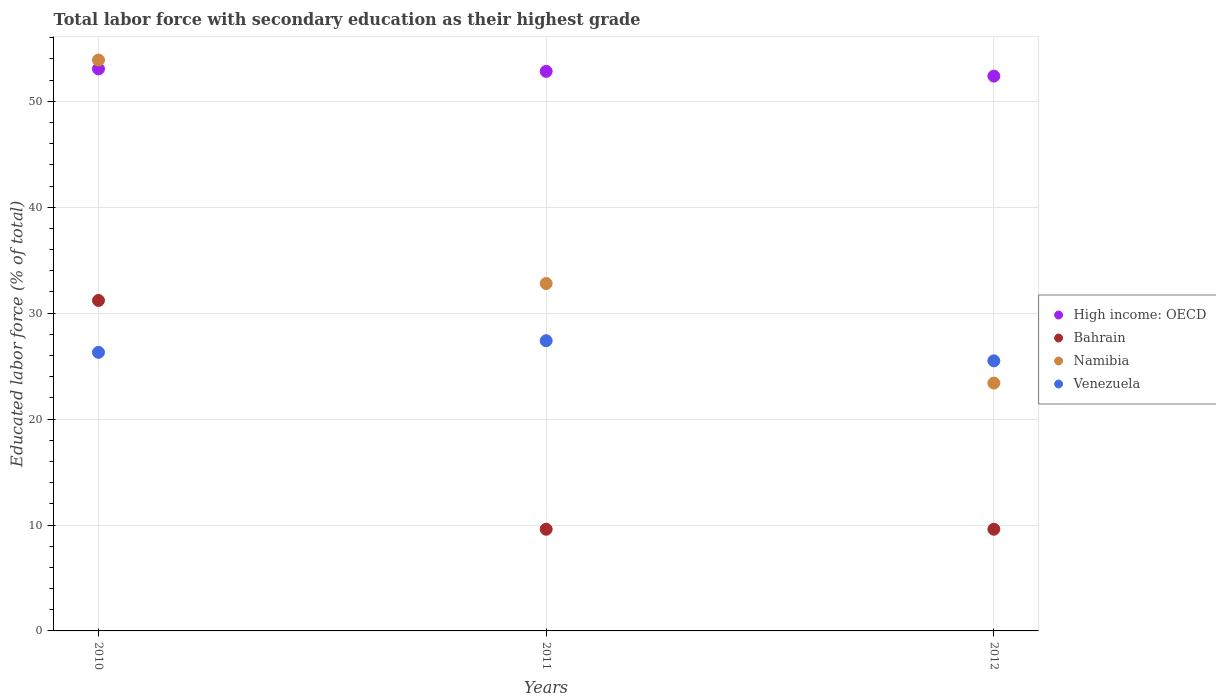How many different coloured dotlines are there?
Your answer should be compact. 4. Is the number of dotlines equal to the number of legend labels?
Provide a short and direct response. Yes. What is the percentage of total labor force with primary education in Bahrain in 2010?
Your answer should be very brief. 31.2. Across all years, what is the maximum percentage of total labor force with primary education in High income: OECD?
Provide a short and direct response. 53.07. Across all years, what is the minimum percentage of total labor force with primary education in High income: OECD?
Offer a terse response. 52.38. In which year was the percentage of total labor force with primary education in Venezuela maximum?
Keep it short and to the point. 2011. What is the total percentage of total labor force with primary education in Venezuela in the graph?
Give a very brief answer. 79.2. What is the difference between the percentage of total labor force with primary education in High income: OECD in 2011 and that in 2012?
Your answer should be very brief. 0.45. What is the difference between the percentage of total labor force with primary education in Namibia in 2011 and the percentage of total labor force with primary education in Venezuela in 2010?
Make the answer very short. 6.5. What is the average percentage of total labor force with primary education in High income: OECD per year?
Offer a terse response. 52.76. In the year 2010, what is the difference between the percentage of total labor force with primary education in High income: OECD and percentage of total labor force with primary education in Namibia?
Offer a terse response. -0.83. What is the ratio of the percentage of total labor force with primary education in High income: OECD in 2010 to that in 2012?
Provide a succinct answer. 1.01. Is the percentage of total labor force with primary education in High income: OECD in 2010 less than that in 2012?
Offer a terse response. No. Is the difference between the percentage of total labor force with primary education in High income: OECD in 2011 and 2012 greater than the difference between the percentage of total labor force with primary education in Namibia in 2011 and 2012?
Your answer should be compact. No. What is the difference between the highest and the second highest percentage of total labor force with primary education in High income: OECD?
Provide a succinct answer. 0.24. What is the difference between the highest and the lowest percentage of total labor force with primary education in High income: OECD?
Your answer should be very brief. 0.68. Does the percentage of total labor force with primary education in Namibia monotonically increase over the years?
Provide a succinct answer. No. Is the percentage of total labor force with primary education in High income: OECD strictly greater than the percentage of total labor force with primary education in Bahrain over the years?
Provide a short and direct response. Yes. What is the difference between two consecutive major ticks on the Y-axis?
Offer a terse response. 10. Are the values on the major ticks of Y-axis written in scientific E-notation?
Make the answer very short. No. Does the graph contain any zero values?
Keep it short and to the point. No. Where does the legend appear in the graph?
Keep it short and to the point. Center right. How are the legend labels stacked?
Your answer should be compact. Vertical. What is the title of the graph?
Keep it short and to the point. Total labor force with secondary education as their highest grade. Does "Bahrain" appear as one of the legend labels in the graph?
Offer a terse response. Yes. What is the label or title of the X-axis?
Give a very brief answer. Years. What is the label or title of the Y-axis?
Ensure brevity in your answer.  Educated labor force (% of total). What is the Educated labor force (% of total) of High income: OECD in 2010?
Provide a succinct answer. 53.07. What is the Educated labor force (% of total) of Bahrain in 2010?
Give a very brief answer. 31.2. What is the Educated labor force (% of total) of Namibia in 2010?
Give a very brief answer. 53.9. What is the Educated labor force (% of total) of Venezuela in 2010?
Keep it short and to the point. 26.3. What is the Educated labor force (% of total) of High income: OECD in 2011?
Your answer should be compact. 52.83. What is the Educated labor force (% of total) of Bahrain in 2011?
Offer a terse response. 9.6. What is the Educated labor force (% of total) in Namibia in 2011?
Provide a short and direct response. 32.8. What is the Educated labor force (% of total) in Venezuela in 2011?
Ensure brevity in your answer.  27.4. What is the Educated labor force (% of total) of High income: OECD in 2012?
Keep it short and to the point. 52.38. What is the Educated labor force (% of total) in Bahrain in 2012?
Provide a succinct answer. 9.6. What is the Educated labor force (% of total) of Namibia in 2012?
Provide a succinct answer. 23.4. Across all years, what is the maximum Educated labor force (% of total) of High income: OECD?
Your answer should be compact. 53.07. Across all years, what is the maximum Educated labor force (% of total) in Bahrain?
Your response must be concise. 31.2. Across all years, what is the maximum Educated labor force (% of total) in Namibia?
Your answer should be very brief. 53.9. Across all years, what is the maximum Educated labor force (% of total) of Venezuela?
Provide a short and direct response. 27.4. Across all years, what is the minimum Educated labor force (% of total) of High income: OECD?
Your answer should be very brief. 52.38. Across all years, what is the minimum Educated labor force (% of total) of Bahrain?
Give a very brief answer. 9.6. Across all years, what is the minimum Educated labor force (% of total) in Namibia?
Keep it short and to the point. 23.4. Across all years, what is the minimum Educated labor force (% of total) in Venezuela?
Your answer should be compact. 25.5. What is the total Educated labor force (% of total) of High income: OECD in the graph?
Your answer should be very brief. 158.28. What is the total Educated labor force (% of total) of Bahrain in the graph?
Provide a succinct answer. 50.4. What is the total Educated labor force (% of total) of Namibia in the graph?
Offer a terse response. 110.1. What is the total Educated labor force (% of total) of Venezuela in the graph?
Offer a very short reply. 79.2. What is the difference between the Educated labor force (% of total) in High income: OECD in 2010 and that in 2011?
Ensure brevity in your answer.  0.24. What is the difference between the Educated labor force (% of total) of Bahrain in 2010 and that in 2011?
Provide a succinct answer. 21.6. What is the difference between the Educated labor force (% of total) in Namibia in 2010 and that in 2011?
Your answer should be compact. 21.1. What is the difference between the Educated labor force (% of total) of Venezuela in 2010 and that in 2011?
Your response must be concise. -1.1. What is the difference between the Educated labor force (% of total) of High income: OECD in 2010 and that in 2012?
Offer a terse response. 0.68. What is the difference between the Educated labor force (% of total) in Bahrain in 2010 and that in 2012?
Offer a very short reply. 21.6. What is the difference between the Educated labor force (% of total) of Namibia in 2010 and that in 2012?
Provide a succinct answer. 30.5. What is the difference between the Educated labor force (% of total) of Venezuela in 2010 and that in 2012?
Provide a short and direct response. 0.8. What is the difference between the Educated labor force (% of total) in High income: OECD in 2011 and that in 2012?
Ensure brevity in your answer.  0.45. What is the difference between the Educated labor force (% of total) in Bahrain in 2011 and that in 2012?
Keep it short and to the point. 0. What is the difference between the Educated labor force (% of total) of High income: OECD in 2010 and the Educated labor force (% of total) of Bahrain in 2011?
Offer a terse response. 43.47. What is the difference between the Educated labor force (% of total) in High income: OECD in 2010 and the Educated labor force (% of total) in Namibia in 2011?
Your response must be concise. 20.27. What is the difference between the Educated labor force (% of total) in High income: OECD in 2010 and the Educated labor force (% of total) in Venezuela in 2011?
Keep it short and to the point. 25.67. What is the difference between the Educated labor force (% of total) in High income: OECD in 2010 and the Educated labor force (% of total) in Bahrain in 2012?
Your response must be concise. 43.47. What is the difference between the Educated labor force (% of total) of High income: OECD in 2010 and the Educated labor force (% of total) of Namibia in 2012?
Provide a short and direct response. 29.67. What is the difference between the Educated labor force (% of total) in High income: OECD in 2010 and the Educated labor force (% of total) in Venezuela in 2012?
Keep it short and to the point. 27.57. What is the difference between the Educated labor force (% of total) in Namibia in 2010 and the Educated labor force (% of total) in Venezuela in 2012?
Your answer should be very brief. 28.4. What is the difference between the Educated labor force (% of total) in High income: OECD in 2011 and the Educated labor force (% of total) in Bahrain in 2012?
Keep it short and to the point. 43.23. What is the difference between the Educated labor force (% of total) of High income: OECD in 2011 and the Educated labor force (% of total) of Namibia in 2012?
Offer a terse response. 29.43. What is the difference between the Educated labor force (% of total) of High income: OECD in 2011 and the Educated labor force (% of total) of Venezuela in 2012?
Give a very brief answer. 27.33. What is the difference between the Educated labor force (% of total) in Bahrain in 2011 and the Educated labor force (% of total) in Namibia in 2012?
Offer a very short reply. -13.8. What is the difference between the Educated labor force (% of total) of Bahrain in 2011 and the Educated labor force (% of total) of Venezuela in 2012?
Offer a very short reply. -15.9. What is the average Educated labor force (% of total) in High income: OECD per year?
Your response must be concise. 52.76. What is the average Educated labor force (% of total) in Namibia per year?
Provide a short and direct response. 36.7. What is the average Educated labor force (% of total) of Venezuela per year?
Make the answer very short. 26.4. In the year 2010, what is the difference between the Educated labor force (% of total) in High income: OECD and Educated labor force (% of total) in Bahrain?
Ensure brevity in your answer.  21.87. In the year 2010, what is the difference between the Educated labor force (% of total) in High income: OECD and Educated labor force (% of total) in Namibia?
Your response must be concise. -0.83. In the year 2010, what is the difference between the Educated labor force (% of total) of High income: OECD and Educated labor force (% of total) of Venezuela?
Your answer should be compact. 26.77. In the year 2010, what is the difference between the Educated labor force (% of total) of Bahrain and Educated labor force (% of total) of Namibia?
Offer a terse response. -22.7. In the year 2010, what is the difference between the Educated labor force (% of total) in Namibia and Educated labor force (% of total) in Venezuela?
Provide a short and direct response. 27.6. In the year 2011, what is the difference between the Educated labor force (% of total) of High income: OECD and Educated labor force (% of total) of Bahrain?
Give a very brief answer. 43.23. In the year 2011, what is the difference between the Educated labor force (% of total) of High income: OECD and Educated labor force (% of total) of Namibia?
Your answer should be compact. 20.03. In the year 2011, what is the difference between the Educated labor force (% of total) in High income: OECD and Educated labor force (% of total) in Venezuela?
Keep it short and to the point. 25.43. In the year 2011, what is the difference between the Educated labor force (% of total) in Bahrain and Educated labor force (% of total) in Namibia?
Make the answer very short. -23.2. In the year 2011, what is the difference between the Educated labor force (% of total) of Bahrain and Educated labor force (% of total) of Venezuela?
Provide a short and direct response. -17.8. In the year 2012, what is the difference between the Educated labor force (% of total) in High income: OECD and Educated labor force (% of total) in Bahrain?
Offer a terse response. 42.78. In the year 2012, what is the difference between the Educated labor force (% of total) of High income: OECD and Educated labor force (% of total) of Namibia?
Your answer should be very brief. 28.98. In the year 2012, what is the difference between the Educated labor force (% of total) in High income: OECD and Educated labor force (% of total) in Venezuela?
Offer a very short reply. 26.88. In the year 2012, what is the difference between the Educated labor force (% of total) in Bahrain and Educated labor force (% of total) in Venezuela?
Your response must be concise. -15.9. What is the ratio of the Educated labor force (% of total) of High income: OECD in 2010 to that in 2011?
Offer a very short reply. 1. What is the ratio of the Educated labor force (% of total) of Namibia in 2010 to that in 2011?
Provide a short and direct response. 1.64. What is the ratio of the Educated labor force (% of total) in Venezuela in 2010 to that in 2011?
Give a very brief answer. 0.96. What is the ratio of the Educated labor force (% of total) of Namibia in 2010 to that in 2012?
Your response must be concise. 2.3. What is the ratio of the Educated labor force (% of total) of Venezuela in 2010 to that in 2012?
Give a very brief answer. 1.03. What is the ratio of the Educated labor force (% of total) of High income: OECD in 2011 to that in 2012?
Provide a short and direct response. 1.01. What is the ratio of the Educated labor force (% of total) of Namibia in 2011 to that in 2012?
Your answer should be compact. 1.4. What is the ratio of the Educated labor force (% of total) in Venezuela in 2011 to that in 2012?
Your response must be concise. 1.07. What is the difference between the highest and the second highest Educated labor force (% of total) of High income: OECD?
Keep it short and to the point. 0.24. What is the difference between the highest and the second highest Educated labor force (% of total) of Bahrain?
Give a very brief answer. 21.6. What is the difference between the highest and the second highest Educated labor force (% of total) of Namibia?
Ensure brevity in your answer.  21.1. What is the difference between the highest and the second highest Educated labor force (% of total) of Venezuela?
Make the answer very short. 1.1. What is the difference between the highest and the lowest Educated labor force (% of total) of High income: OECD?
Give a very brief answer. 0.68. What is the difference between the highest and the lowest Educated labor force (% of total) in Bahrain?
Offer a terse response. 21.6. What is the difference between the highest and the lowest Educated labor force (% of total) in Namibia?
Offer a very short reply. 30.5. 